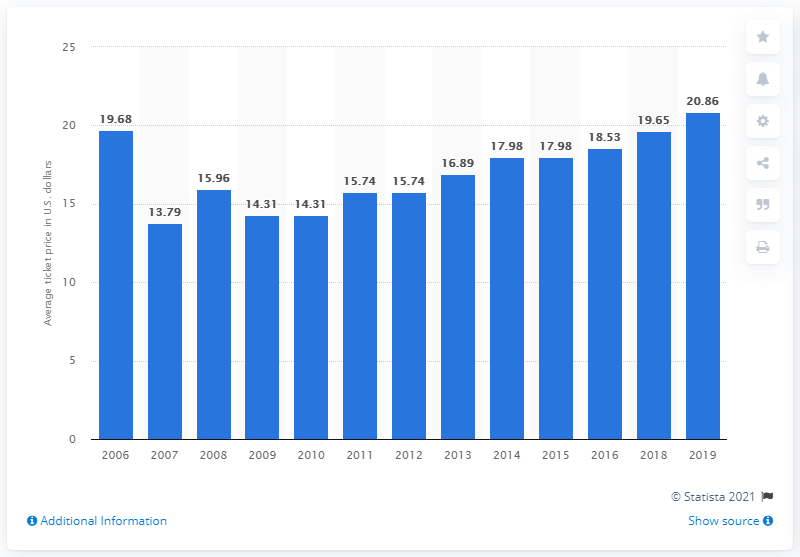Outline some significant characteristics in this image. In 2019, the average ticket price for Arizona Diamondbacks games was $20.86 per ticket. In 2019, the average ticket price for Arizona Diamondbacks games was $20.86 per ticket. 